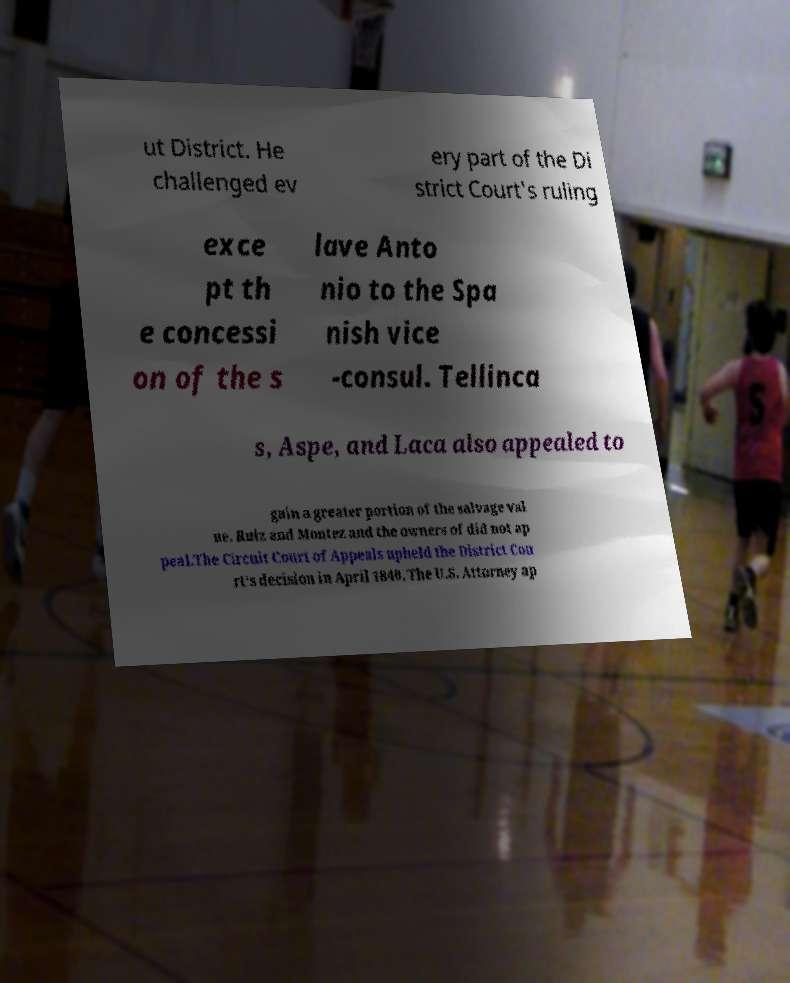Can you accurately transcribe the text from the provided image for me? ut District. He challenged ev ery part of the Di strict Court's ruling exce pt th e concessi on of the s lave Anto nio to the Spa nish vice -consul. Tellinca s, Aspe, and Laca also appealed to gain a greater portion of the salvage val ue. Ruiz and Montez and the owners of did not ap peal.The Circuit Court of Appeals upheld the District Cou rt's decision in April 1840. The U.S. Attorney ap 